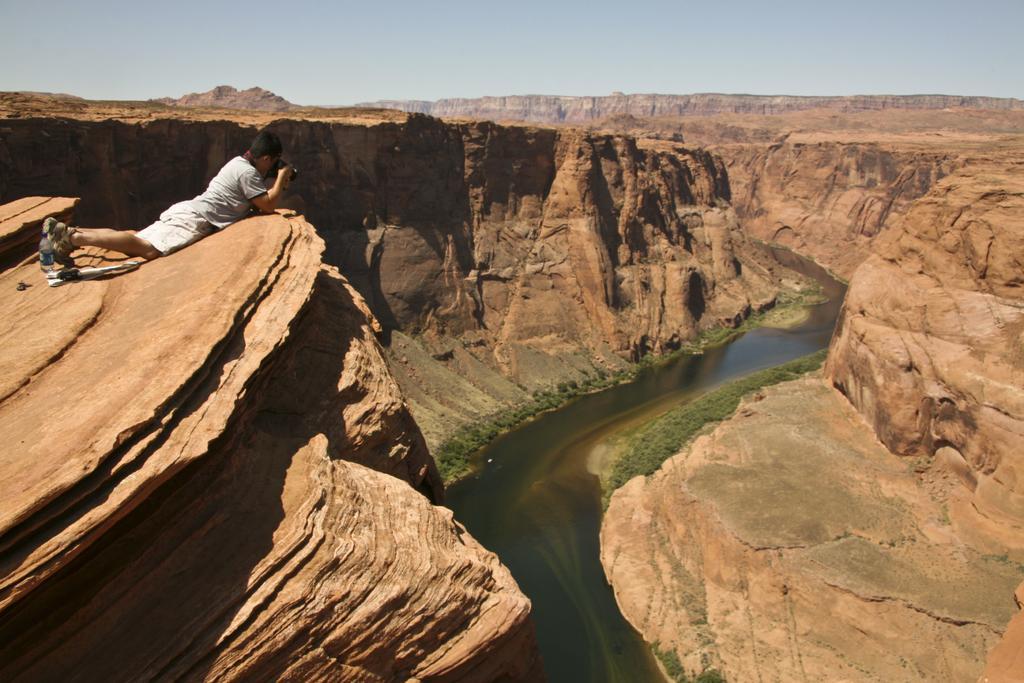Can you describe this image briefly? In this image we can see the mountains around the river. We can also see some plants and a person lying down taking the picture in a camera. On the backside we can see the sky which looks cloudy. 